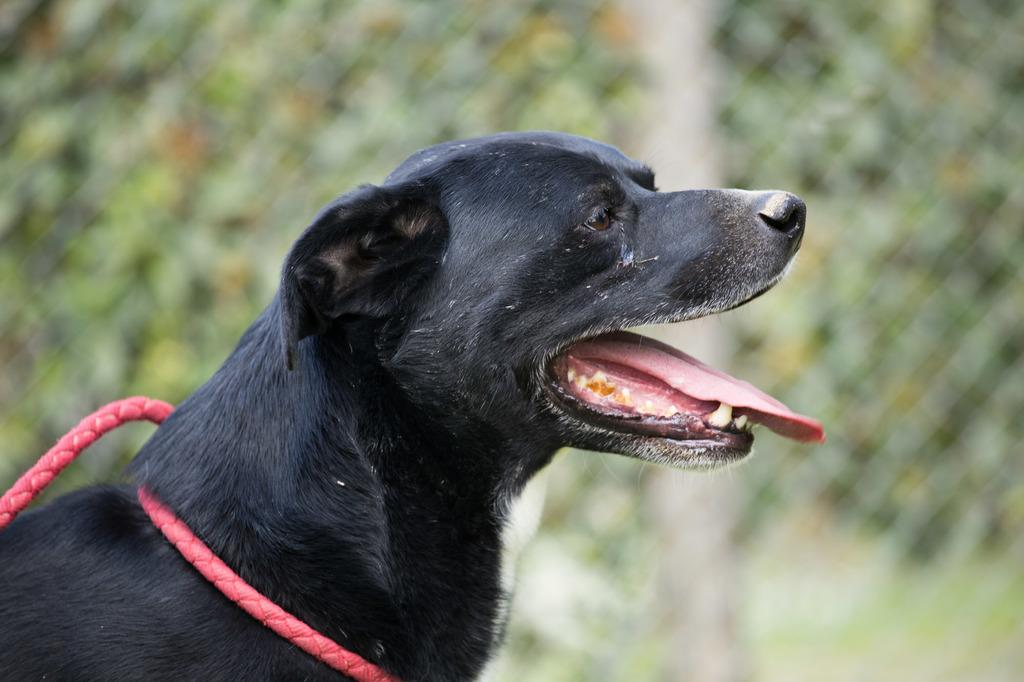What type of animal is in the image? There is a black color dog in the image. In which direction is the dog facing? The dog is facing towards the right side. What is around the dog's neck? The dog has a red color belt around its neck. Can you describe the background of the image? The background of the image is blurred. What type of plants can be seen growing around the dog's neck in the image? There are no plants visible in the image, and the dog is not wearing any plants around its neck. 